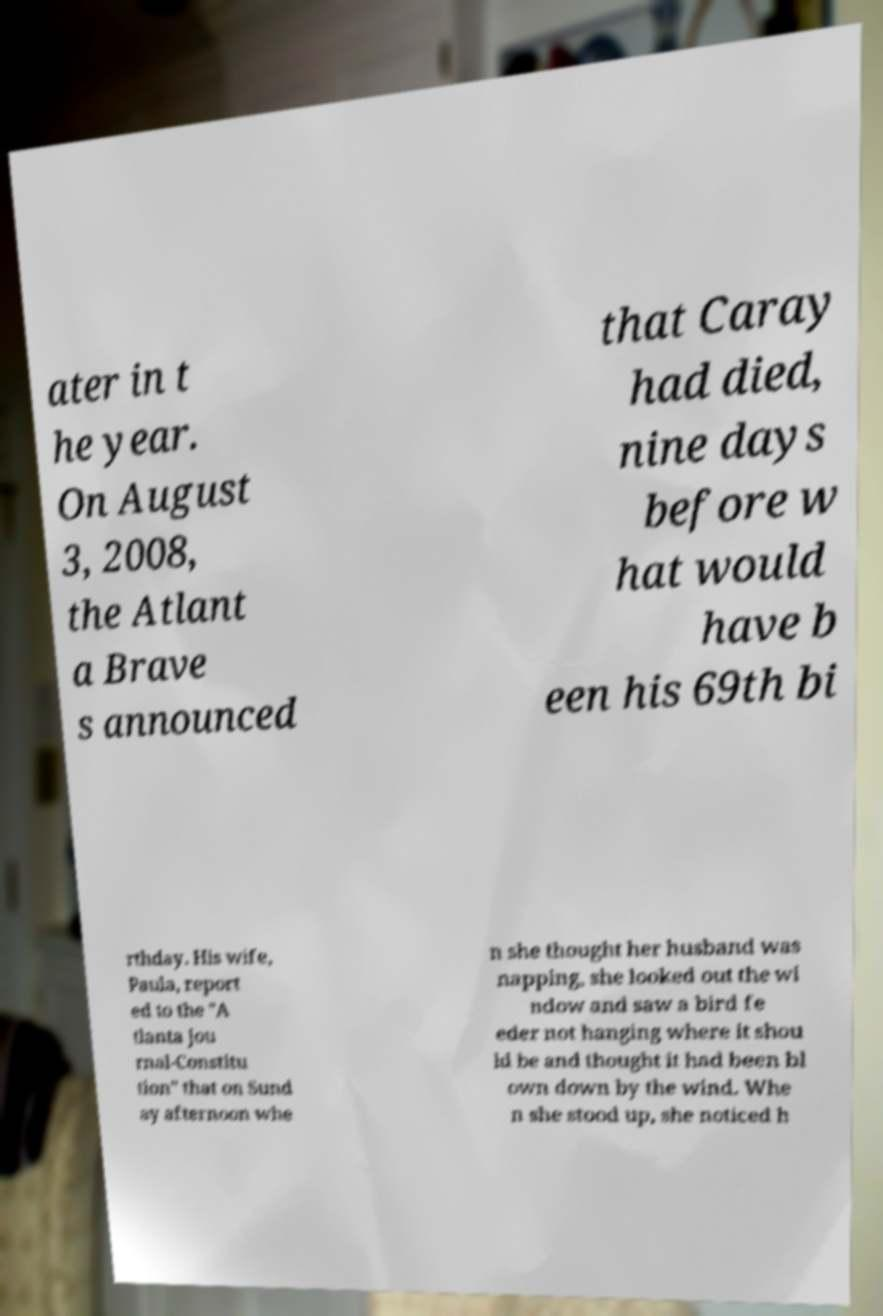I need the written content from this picture converted into text. Can you do that? ater in t he year. On August 3, 2008, the Atlant a Brave s announced that Caray had died, nine days before w hat would have b een his 69th bi rthday. His wife, Paula, report ed to the "A tlanta Jou rnal-Constitu tion" that on Sund ay afternoon whe n she thought her husband was napping, she looked out the wi ndow and saw a bird fe eder not hanging where it shou ld be and thought it had been bl own down by the wind. Whe n she stood up, she noticed h 